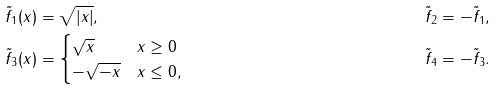<formula> <loc_0><loc_0><loc_500><loc_500>\tilde { f } _ { 1 } ( x ) & = \sqrt { | x | } , & \tilde { f } _ { 2 } & = - \tilde { f } _ { 1 } , \\ \tilde { f } _ { 3 } ( x ) & = \begin{cases} \sqrt { x } & x \geq 0 \\ - \sqrt { - x } & x \leq 0 , \end{cases} & \tilde { f } _ { 4 } & = - \tilde { f } _ { 3 } .</formula> 